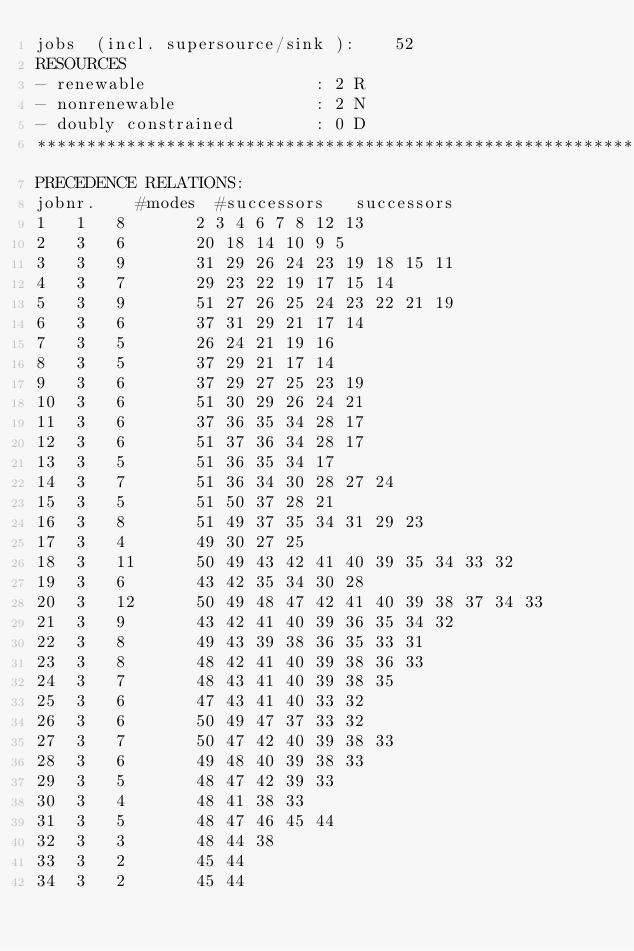Convert code to text. <code><loc_0><loc_0><loc_500><loc_500><_ObjectiveC_>jobs  (incl. supersource/sink ):	52
RESOURCES
- renewable                 : 2 R
- nonrenewable              : 2 N
- doubly constrained        : 0 D
************************************************************************
PRECEDENCE RELATIONS:
jobnr.    #modes  #successors   successors
1	1	8		2 3 4 6 7 8 12 13 
2	3	6		20 18 14 10 9 5 
3	3	9		31 29 26 24 23 19 18 15 11 
4	3	7		29 23 22 19 17 15 14 
5	3	9		51 27 26 25 24 23 22 21 19 
6	3	6		37 31 29 21 17 14 
7	3	5		26 24 21 19 16 
8	3	5		37 29 21 17 14 
9	3	6		37 29 27 25 23 19 
10	3	6		51 30 29 26 24 21 
11	3	6		37 36 35 34 28 17 
12	3	6		51 37 36 34 28 17 
13	3	5		51 36 35 34 17 
14	3	7		51 36 34 30 28 27 24 
15	3	5		51 50 37 28 21 
16	3	8		51 49 37 35 34 31 29 23 
17	3	4		49 30 27 25 
18	3	11		50 49 43 42 41 40 39 35 34 33 32 
19	3	6		43 42 35 34 30 28 
20	3	12		50 49 48 47 42 41 40 39 38 37 34 33 
21	3	9		43 42 41 40 39 36 35 34 32 
22	3	8		49 43 39 38 36 35 33 31 
23	3	8		48 42 41 40 39 38 36 33 
24	3	7		48 43 41 40 39 38 35 
25	3	6		47 43 41 40 33 32 
26	3	6		50 49 47 37 33 32 
27	3	7		50 47 42 40 39 38 33 
28	3	6		49 48 40 39 38 33 
29	3	5		48 47 42 39 33 
30	3	4		48 41 38 33 
31	3	5		48 47 46 45 44 
32	3	3		48 44 38 
33	3	2		45 44 
34	3	2		45 44 </code> 